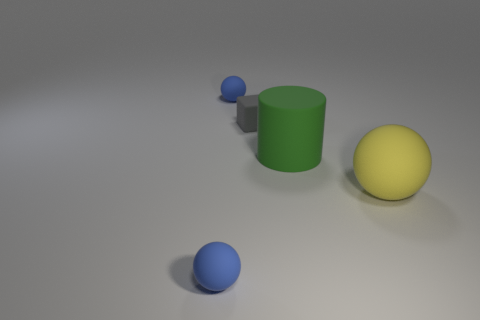What shape is the yellow thing that is the same material as the green cylinder?
Make the answer very short. Sphere. There is a tiny blue object that is behind the rubber block; does it have the same shape as the big green rubber thing?
Offer a terse response. No. The tiny blue rubber object behind the tiny cube has what shape?
Your answer should be very brief. Sphere. How many other cylinders have the same size as the green matte cylinder?
Your answer should be very brief. 0. The large matte cylinder has what color?
Provide a succinct answer. Green. There is a big cylinder; is it the same color as the small matte ball that is behind the yellow rubber thing?
Ensure brevity in your answer.  No. There is a gray thing that is the same material as the large yellow object; what size is it?
Provide a short and direct response. Small. Are there any matte objects that have the same color as the tiny cube?
Offer a terse response. No. How many things are tiny blue things that are in front of the green matte cylinder or large blue matte cubes?
Keep it short and to the point. 1. Is the material of the big cylinder the same as the blue ball behind the tiny gray matte object?
Provide a short and direct response. Yes. 